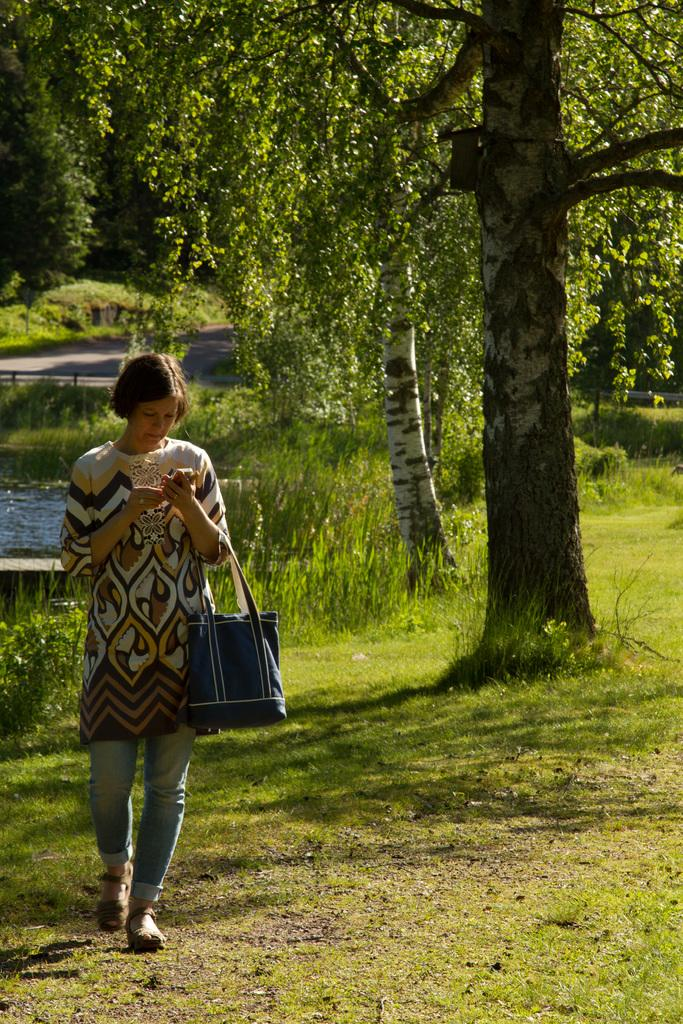Who is present in the image? There is a woman in the image. What is the woman doing in the image? The woman is walking in the garden. What is the woman holding in the image? The woman is holding a blue color bag. What type of natural environment can be seen in the image? There is a tree, grass, and plants visible in the image. What type of water feature is present in the image? There is a small pool in the image. How many potatoes can be seen growing in the garden in the image? There are no potatoes visible in the image; it features a woman walking in a garden with a tree, grass, plants, and a small pool. What type of spiders can be seen crawling on the woman's bag in the image? There are no spiders present in the image; the woman is holding a blue color bag. 